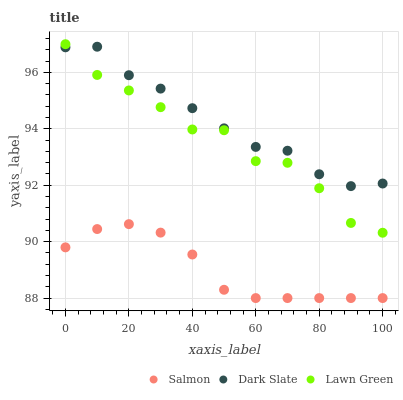Does Salmon have the minimum area under the curve?
Answer yes or no. Yes. Does Dark Slate have the maximum area under the curve?
Answer yes or no. Yes. Does Lawn Green have the minimum area under the curve?
Answer yes or no. No. Does Lawn Green have the maximum area under the curve?
Answer yes or no. No. Is Salmon the smoothest?
Answer yes or no. Yes. Is Lawn Green the roughest?
Answer yes or no. Yes. Is Lawn Green the smoothest?
Answer yes or no. No. Is Salmon the roughest?
Answer yes or no. No. Does Salmon have the lowest value?
Answer yes or no. Yes. Does Lawn Green have the lowest value?
Answer yes or no. No. Does Lawn Green have the highest value?
Answer yes or no. Yes. Does Salmon have the highest value?
Answer yes or no. No. Is Salmon less than Lawn Green?
Answer yes or no. Yes. Is Lawn Green greater than Salmon?
Answer yes or no. Yes. Does Lawn Green intersect Dark Slate?
Answer yes or no. Yes. Is Lawn Green less than Dark Slate?
Answer yes or no. No. Is Lawn Green greater than Dark Slate?
Answer yes or no. No. Does Salmon intersect Lawn Green?
Answer yes or no. No. 